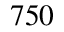Convert formula to latex. <formula><loc_0><loc_0><loc_500><loc_500>7 5 0</formula> 